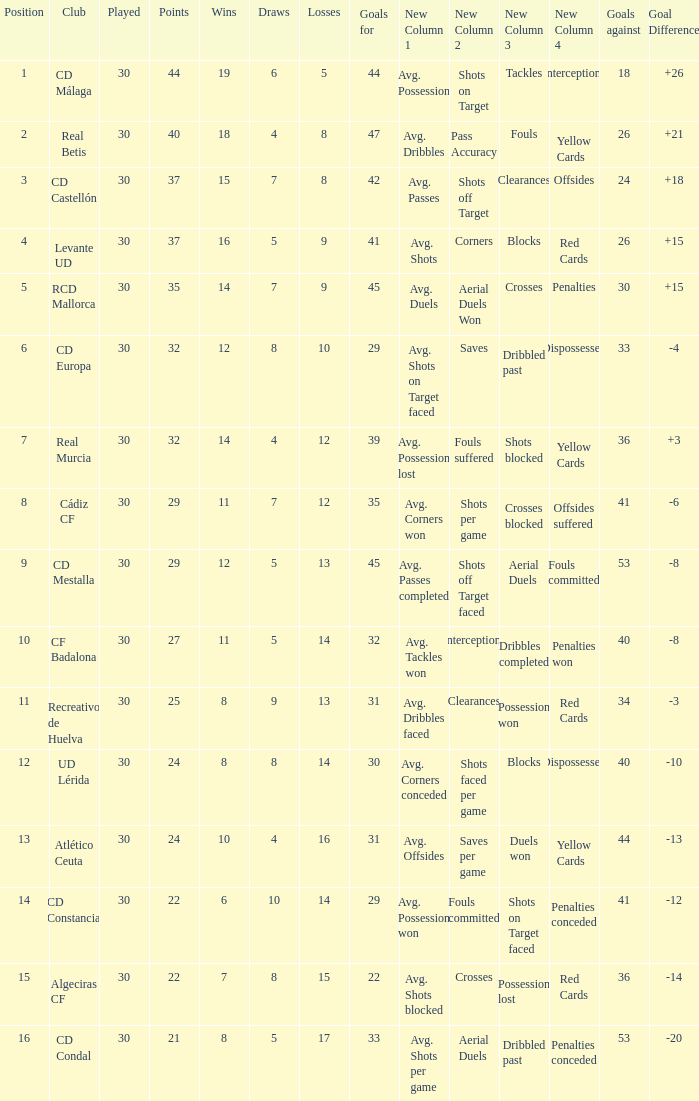What is the goals for when played is larger than 30? None. 